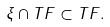<formula> <loc_0><loc_0><loc_500><loc_500>\xi \cap T F \subset T F .</formula> 